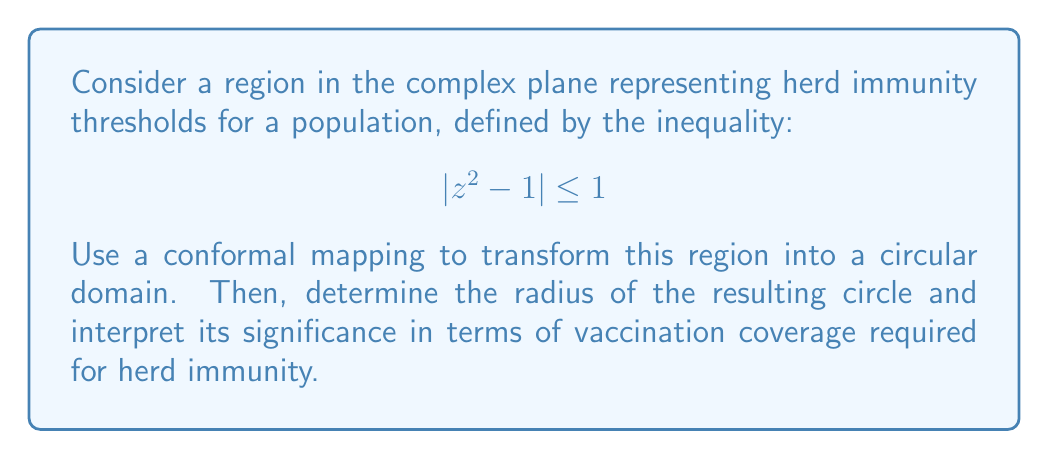Teach me how to tackle this problem. To solve this problem, we'll follow these steps:

1) First, let's recognize the given region. It's a lemniscate centered at the origin.

2) To transform this region into a circular domain, we can use the conformal mapping:

   $$ w = \frac{z^2 - 1}{z^2 + 1} $$

3) This mapping sends the lemniscate to the unit circle in the w-plane.

4) To prove this, let's consider a point z on the boundary of the lemniscate:
   
   $$ |z^2 - 1| = 1 $$

5) Substituting this into our mapping:

   $$ |w| = \left|\frac{z^2 - 1}{z^2 + 1}\right| = \frac{|z^2 - 1|}{|z^2 + 1|} = \frac{1}{|z^2 + 1|} $$

6) But on the lemniscate, $|z^2 - 1| = 1$, so $|z^2 + 1| = |(z^2 - 1) + 2| \leq |z^2 - 1| + |2| = 1 + 2 = 3$

7) Therefore, $|w| \geq \frac{1}{3}$

8) The equality holds when $z = \pm i$, which are mapped to $w = -\frac{1}{3}$

9) Thus, the lemniscate is mapped to a circle with radius $\frac{1}{3}$ centered at the origin in the w-plane.

Interpretation: In the context of herd immunity, we can interpret the radius of $\frac{1}{3}$ as representing a vaccination coverage of 33.33% required for herd immunity. This is a simplified model and actual herd immunity thresholds vary depending on the disease and population characteristics. As a general practitioner skeptical of anti-vaccination claims, you would note that this simplified mathematical model underestimates the actual vaccination coverage required for most diseases (which is typically 70-90%), emphasizing the importance of high vaccination rates for effective herd immunity.
Answer: The conformal mapping $w = \frac{z^2 - 1}{z^2 + 1}$ transforms the given lemniscate into a circle with radius $\frac{1}{3}$ centered at the origin in the w-plane. 